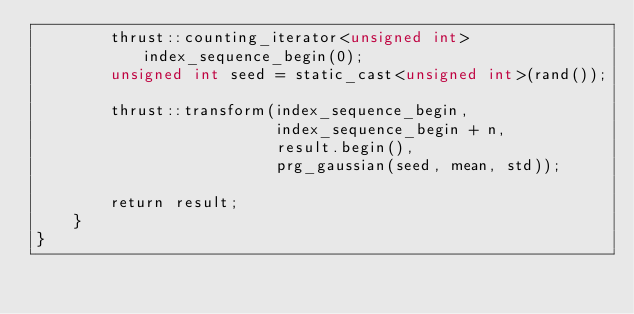Convert code to text. <code><loc_0><loc_0><loc_500><loc_500><_Cuda_>        thrust::counting_iterator<unsigned int> index_sequence_begin(0);
        unsigned int seed = static_cast<unsigned int>(rand());

        thrust::transform(index_sequence_begin,
                          index_sequence_begin + n,
                          result.begin(),
                          prg_gaussian(seed, mean, std));

        return result;
    }
}
</code> 